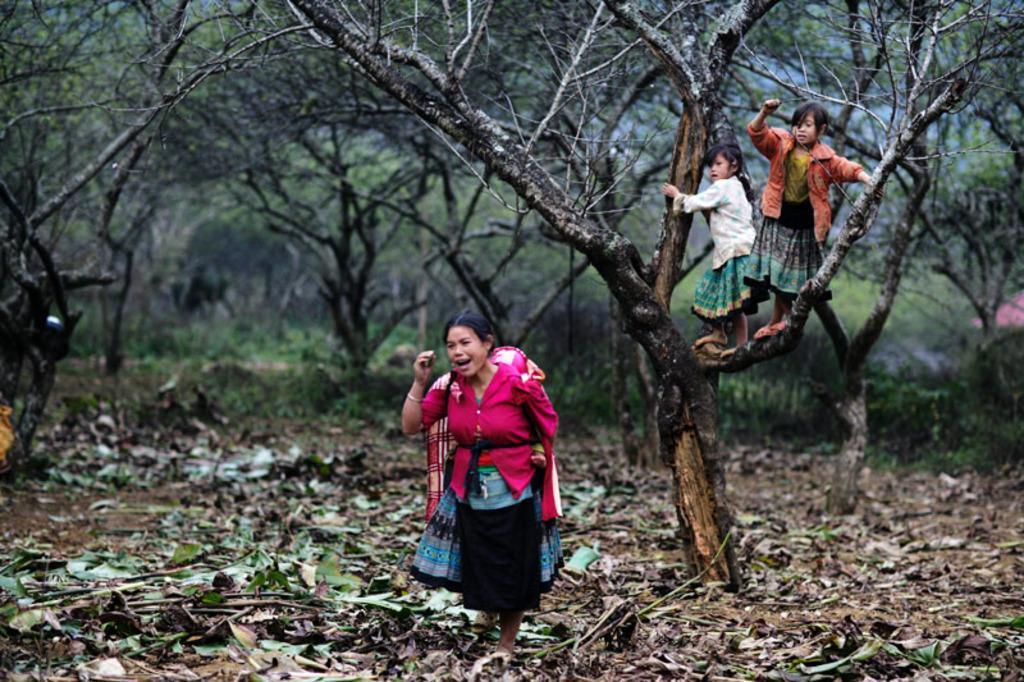In one or two sentences, can you explain what this image depicts? In this image, there are a few people. We can see some plants, trees. We can see the ground with some objects like dried leaves. We can also see an object on the right. 